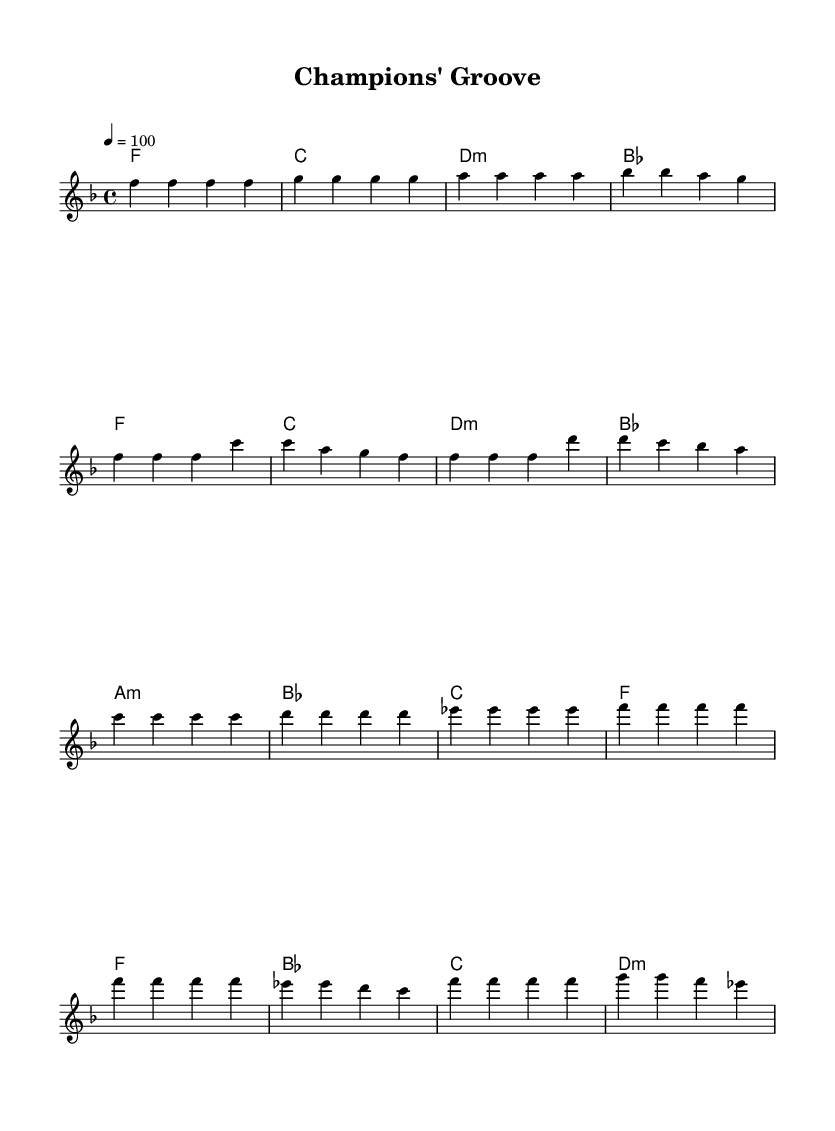What is the key signature of this music? The key signature is F major, which has one flat (B flat). It can be found at the beginning of the staff before the notes are notated.
Answer: F major What is the time signature of the piece? The time signature is 4/4, which indicates there are four beats in each measure. This is seen at the beginning of the score where the time signature is displayed.
Answer: 4/4 What is the tempo marking of this music? The tempo marking is 100 beats per minute, indicated by the "4 = 100" notation at the beginning of the score. This tells performers the pace to play the piece.
Answer: 100 How many bars are there in the chorus section? The chorus section has four bars, determined by counting each measure indicated in the notation. The organization of the music into sections allows for clear identification of these bars.
Answer: 4 What is the first chord in the intro? The first chord in the intro is F major, which is indicated by the chord names below the melody staff. This chord sets the initial harmony for the piece.
Answer: F What type of music structure is used in this piece? This piece follows a verse-pre-chorus-chorus structure, commonly found in modern R&B anthems. This organization helps to convey a narrative and enhance the celebratory theme of success.
Answer: Verse-pre-chorus-chorus What harmonic mode is used in the pre-chorus? The harmonic mode used in the pre-chorus is A minor, which is noted in the chord progression shown beneath the melody. The presence of A minor reinforces the emotional weight often present in R&B music.
Answer: A minor 